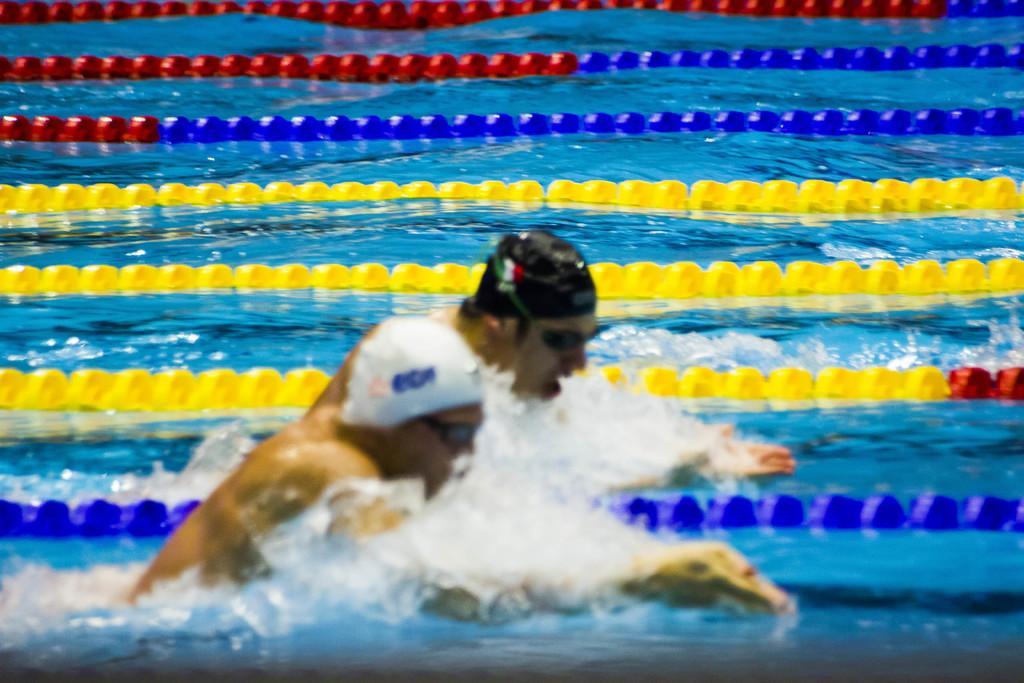Can you describe this image briefly? The picture consists of a swimming pool, in the pool there are two people swimming and there are some ribbon like objects floating. 